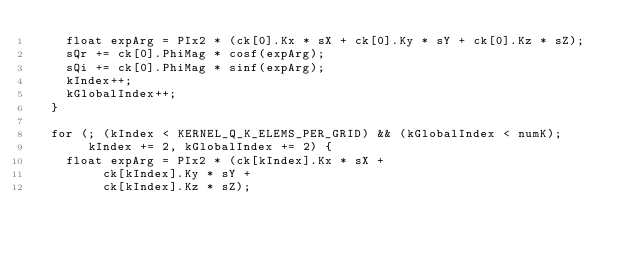<code> <loc_0><loc_0><loc_500><loc_500><_Cuda_>    float expArg = PIx2 * (ck[0].Kx * sX + ck[0].Ky * sY + ck[0].Kz * sZ);
    sQr += ck[0].PhiMag * cosf(expArg);
    sQi += ck[0].PhiMag * sinf(expArg);
    kIndex++;
    kGlobalIndex++;
  }

  for (; (kIndex < KERNEL_Q_K_ELEMS_PER_GRID) && (kGlobalIndex < numK);
       kIndex += 2, kGlobalIndex += 2) {
    float expArg = PIx2 * (ck[kIndex].Kx * sX +
			   ck[kIndex].Ky * sY +
			   ck[kIndex].Kz * sZ);</code> 